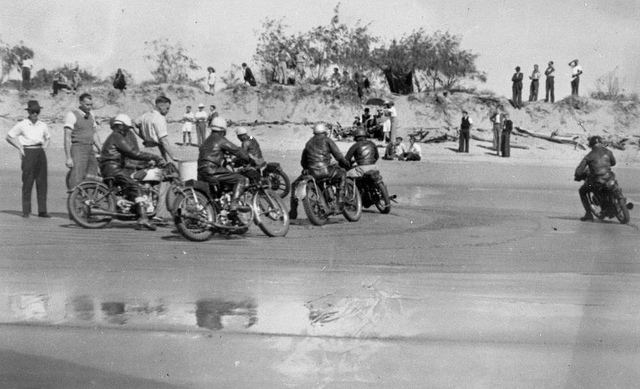Create a modern-day fictional scenario inspired by the image. In a modern-day scenario inspired by the image, imagine a group of motorcycle enthusiasts who gather every summer for a unique beach racing event. This annual event attracts racers and spectators from around the world, transforming a quiet coastal town into a bustling hub of excitement. The participants, ranging from seasoned professionals to daring amateurs, race on specially designed eco-friendly bikes that respect the natural beauty of the beach. The event is a celebration of innovation, with state-of-the-art racing technology on display. Spectators can enjoy the race from grandstands built into the dunes, with digital screens providing up-close views of the high-speed action. After the races, the town hosts a vibrant festival, with local food, music, and crafts, celebrating both the thrill of the races and the charm of the coastal community. Describe how the beach environment impacts the race. The beach environment presents a unique set of challenges and dynamics that impact the race. The hard-packed sand provides a relatively smooth surface for high-speed racing, but it can also shift unexpectedly, requiring riders to have excellent control and quick reflexes. The proximity to the ocean means that moisture in the air and occasional splashes of seawater can affect visibility and traction. Wind conditions, often unpredictable on the beach, can create resistance or aid, depending on its direction. The natural dunes and flat expanses offer varying terrains, demanding versatile riding skills. Moreover, the picturesque backdrop of the sea and sky adds a spectacular visual element to the race, making it a thrilling experience not just for the participants but also for the audience. 